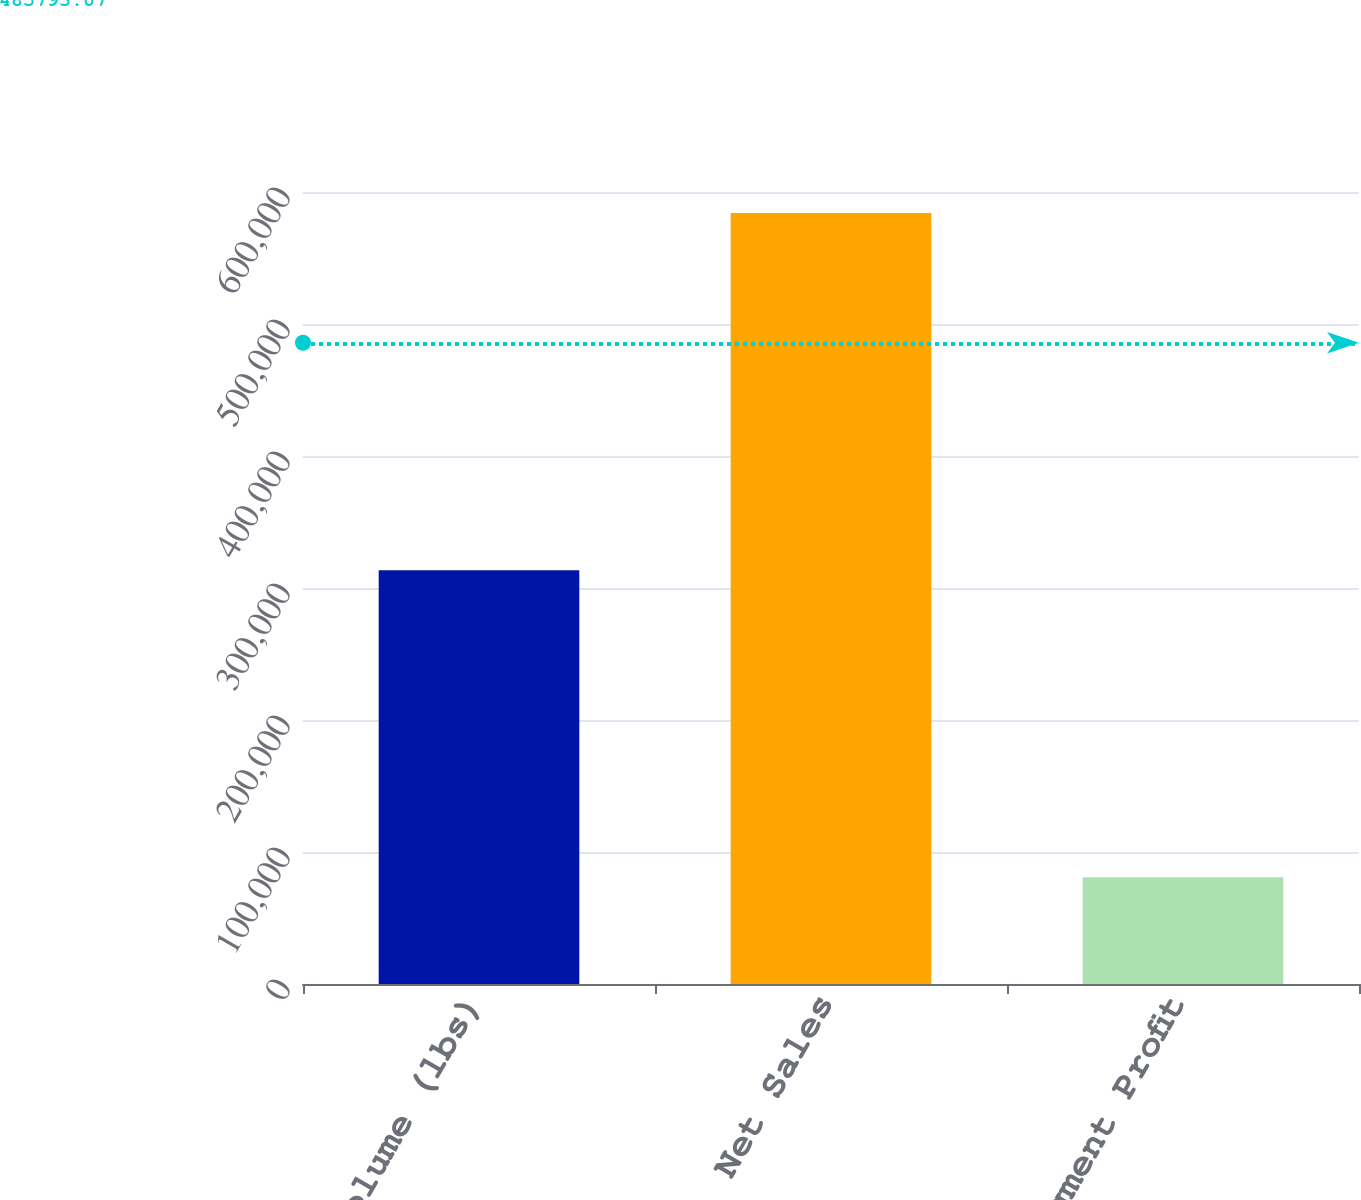Convert chart to OTSL. <chart><loc_0><loc_0><loc_500><loc_500><bar_chart><fcel>Volume (lbs)<fcel>Net Sales<fcel>Segment Profit<nl><fcel>313489<fcel>584085<fcel>80923<nl></chart> 